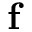Convert formula to latex. <formula><loc_0><loc_0><loc_500><loc_500>f</formula> 